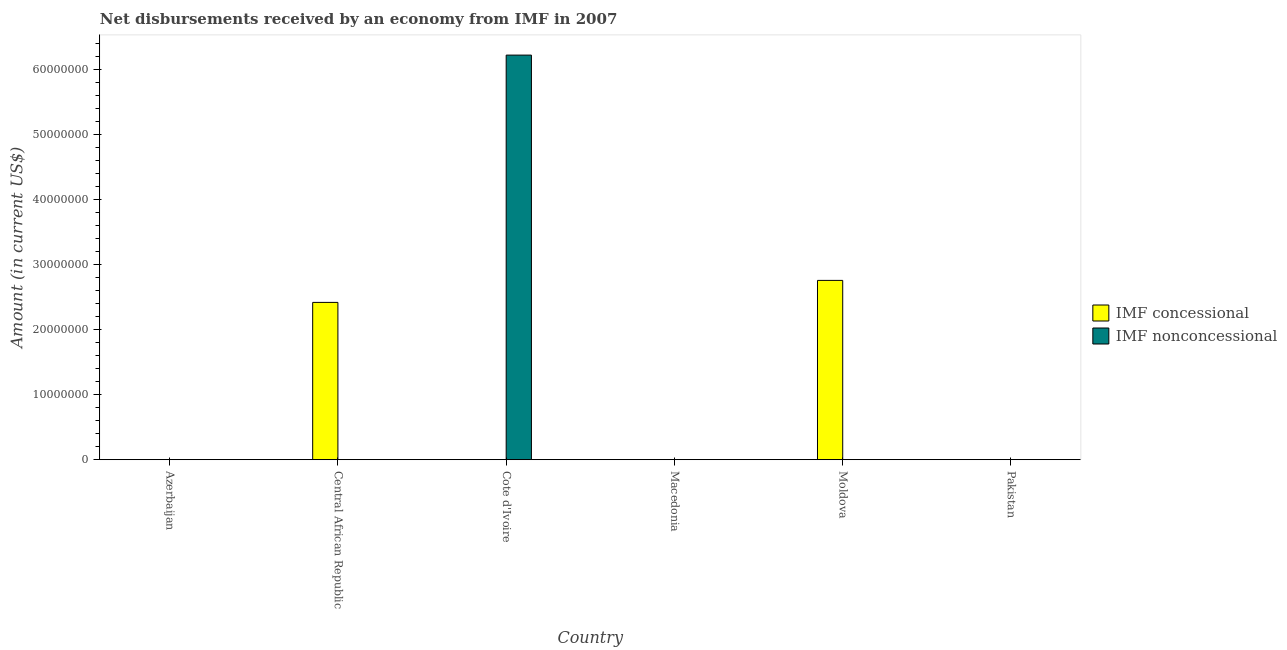How many different coloured bars are there?
Provide a short and direct response. 2. Are the number of bars per tick equal to the number of legend labels?
Offer a very short reply. No. Are the number of bars on each tick of the X-axis equal?
Offer a terse response. No. How many bars are there on the 4th tick from the left?
Offer a terse response. 0. How many bars are there on the 5th tick from the right?
Provide a succinct answer. 1. What is the label of the 2nd group of bars from the left?
Your answer should be very brief. Central African Republic. In how many cases, is the number of bars for a given country not equal to the number of legend labels?
Provide a short and direct response. 6. Across all countries, what is the maximum net concessional disbursements from imf?
Provide a short and direct response. 2.76e+07. Across all countries, what is the minimum net non concessional disbursements from imf?
Keep it short and to the point. 0. In which country was the net non concessional disbursements from imf maximum?
Ensure brevity in your answer.  Cote d'Ivoire. What is the total net non concessional disbursements from imf in the graph?
Provide a succinct answer. 6.22e+07. What is the average net non concessional disbursements from imf per country?
Your response must be concise. 1.04e+07. What is the difference between the highest and the lowest net concessional disbursements from imf?
Your answer should be compact. 2.76e+07. In how many countries, is the net concessional disbursements from imf greater than the average net concessional disbursements from imf taken over all countries?
Your answer should be very brief. 2. What is the difference between two consecutive major ticks on the Y-axis?
Your response must be concise. 1.00e+07. Are the values on the major ticks of Y-axis written in scientific E-notation?
Provide a short and direct response. No. Where does the legend appear in the graph?
Offer a terse response. Center right. How are the legend labels stacked?
Your response must be concise. Vertical. What is the title of the graph?
Your response must be concise. Net disbursements received by an economy from IMF in 2007. What is the label or title of the X-axis?
Make the answer very short. Country. What is the label or title of the Y-axis?
Keep it short and to the point. Amount (in current US$). What is the Amount (in current US$) in IMF concessional in Central African Republic?
Provide a short and direct response. 2.42e+07. What is the Amount (in current US$) of IMF nonconcessional in Central African Republic?
Give a very brief answer. 0. What is the Amount (in current US$) in IMF concessional in Cote d'Ivoire?
Keep it short and to the point. 0. What is the Amount (in current US$) of IMF nonconcessional in Cote d'Ivoire?
Your answer should be compact. 6.22e+07. What is the Amount (in current US$) of IMF concessional in Moldova?
Your answer should be compact. 2.76e+07. What is the Amount (in current US$) in IMF nonconcessional in Moldova?
Your answer should be compact. 0. Across all countries, what is the maximum Amount (in current US$) of IMF concessional?
Offer a very short reply. 2.76e+07. Across all countries, what is the maximum Amount (in current US$) in IMF nonconcessional?
Provide a short and direct response. 6.22e+07. Across all countries, what is the minimum Amount (in current US$) in IMF concessional?
Offer a terse response. 0. What is the total Amount (in current US$) in IMF concessional in the graph?
Provide a short and direct response. 5.18e+07. What is the total Amount (in current US$) of IMF nonconcessional in the graph?
Provide a succinct answer. 6.22e+07. What is the difference between the Amount (in current US$) in IMF concessional in Central African Republic and that in Moldova?
Make the answer very short. -3.38e+06. What is the difference between the Amount (in current US$) of IMF concessional in Central African Republic and the Amount (in current US$) of IMF nonconcessional in Cote d'Ivoire?
Make the answer very short. -3.80e+07. What is the average Amount (in current US$) of IMF concessional per country?
Provide a succinct answer. 8.63e+06. What is the average Amount (in current US$) in IMF nonconcessional per country?
Provide a short and direct response. 1.04e+07. What is the ratio of the Amount (in current US$) in IMF concessional in Central African Republic to that in Moldova?
Keep it short and to the point. 0.88. What is the difference between the highest and the lowest Amount (in current US$) of IMF concessional?
Give a very brief answer. 2.76e+07. What is the difference between the highest and the lowest Amount (in current US$) in IMF nonconcessional?
Keep it short and to the point. 6.22e+07. 